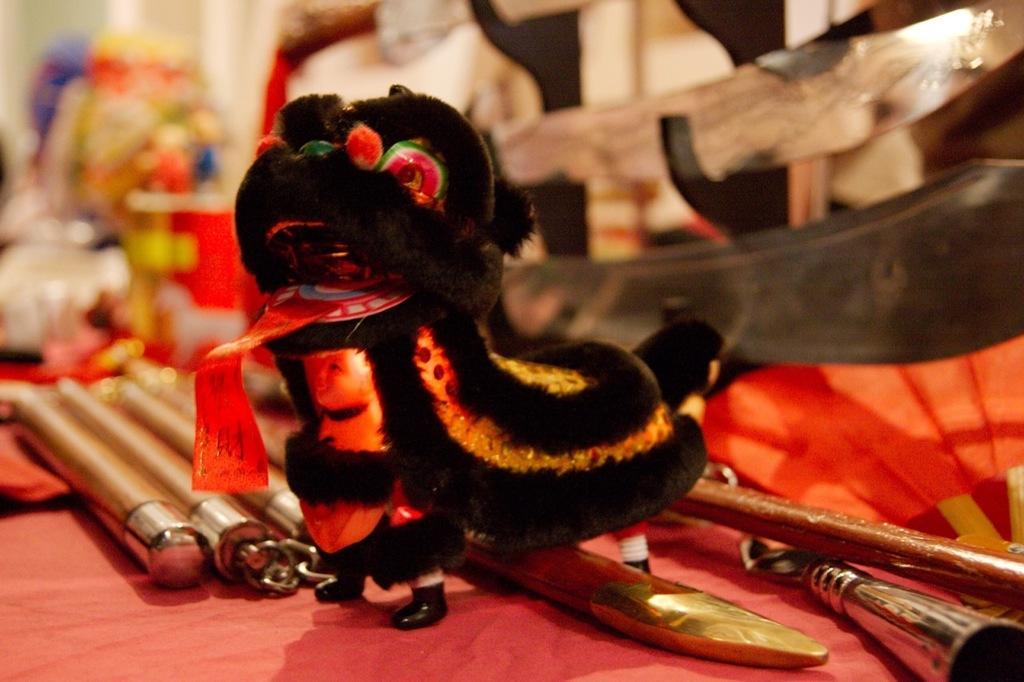Could you give a brief overview of what you see in this image? In this picture we can see a toy and some items on an object and behind the toy there are some blurred objects. 